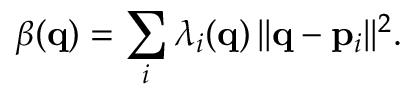Convert formula to latex. <formula><loc_0><loc_0><loc_500><loc_500>\beta ( { q } ) = \sum _ { i } \lambda _ { i } ( { q } ) \, | | { q } - { p } _ { i } | | ^ { 2 } .</formula> 